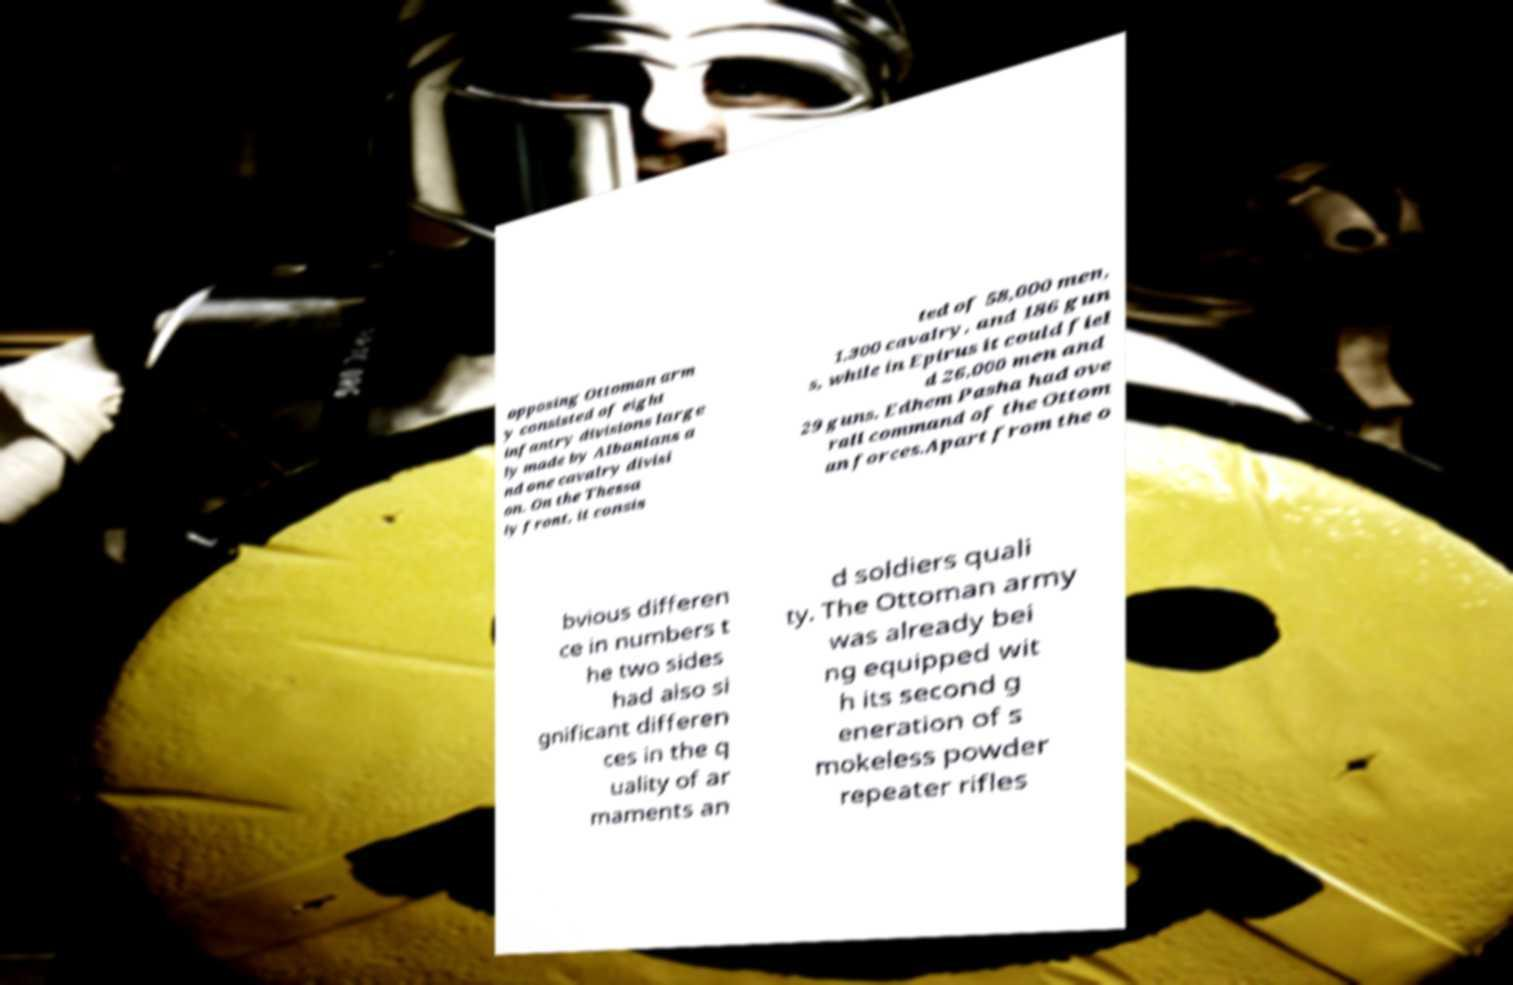There's text embedded in this image that I need extracted. Can you transcribe it verbatim? opposing Ottoman arm y consisted of eight infantry divisions large ly made by Albanians a nd one cavalry divisi on. On the Thessa ly front, it consis ted of 58,000 men, 1,300 cavalry, and 186 gun s, while in Epirus it could fiel d 26,000 men and 29 guns. Edhem Pasha had ove rall command of the Ottom an forces.Apart from the o bvious differen ce in numbers t he two sides had also si gnificant differen ces in the q uality of ar maments an d soldiers quali ty. The Ottoman army was already bei ng equipped wit h its second g eneration of s mokeless powder repeater rifles 